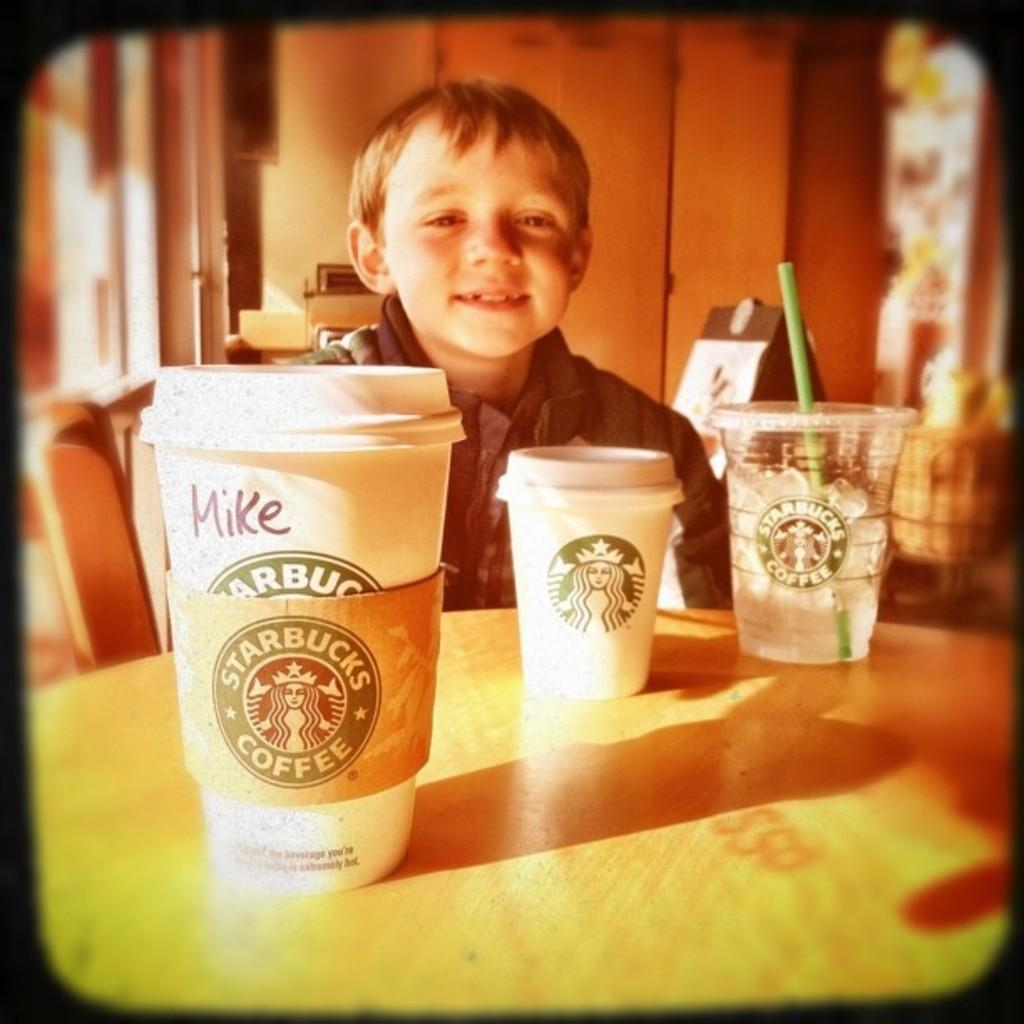<image>
Relay a brief, clear account of the picture shown. Three starbucks cups are on a table in front of a boy. 